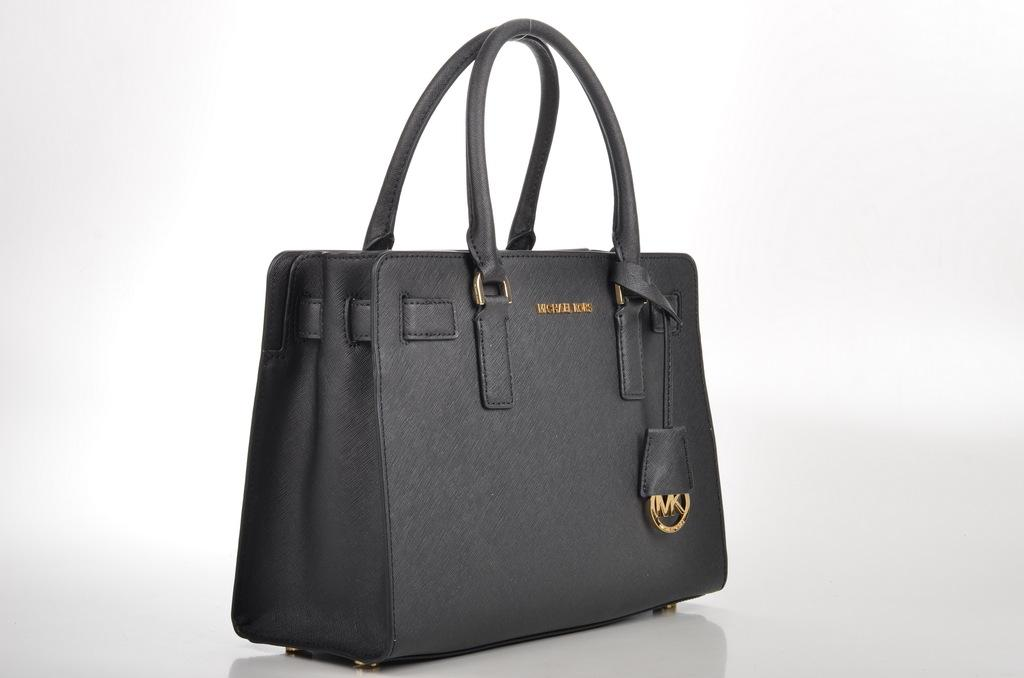What type of bag is visible in the image? There is a black handbag in the image. What is the color of the surface on which the handbag is placed? The handbag is placed on a white surface. What type of plantation can be seen in the background of the image? There is no plantation visible in the image; it only features a black handbag placed on a white surface. 